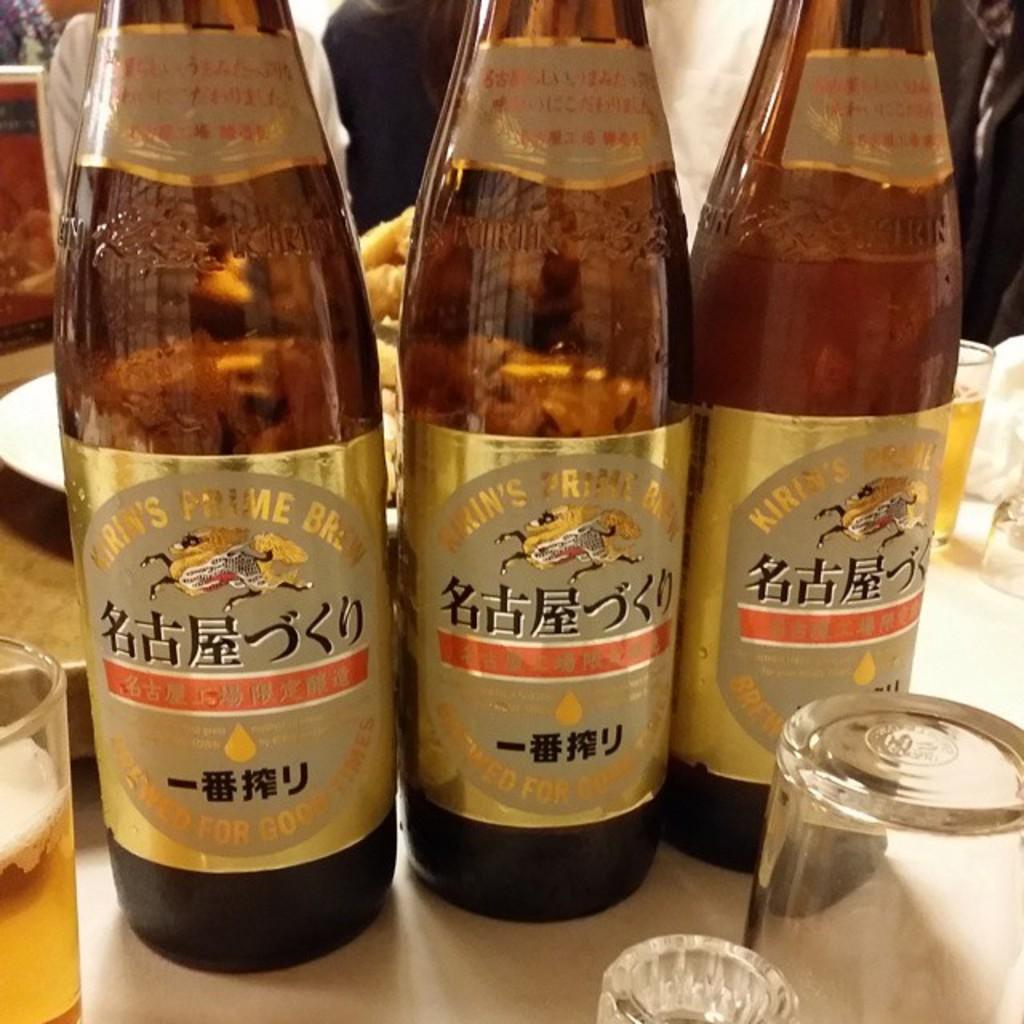Provide a one-sentence caption for the provided image. 3 beers bottles side by side branded Kirin's. 